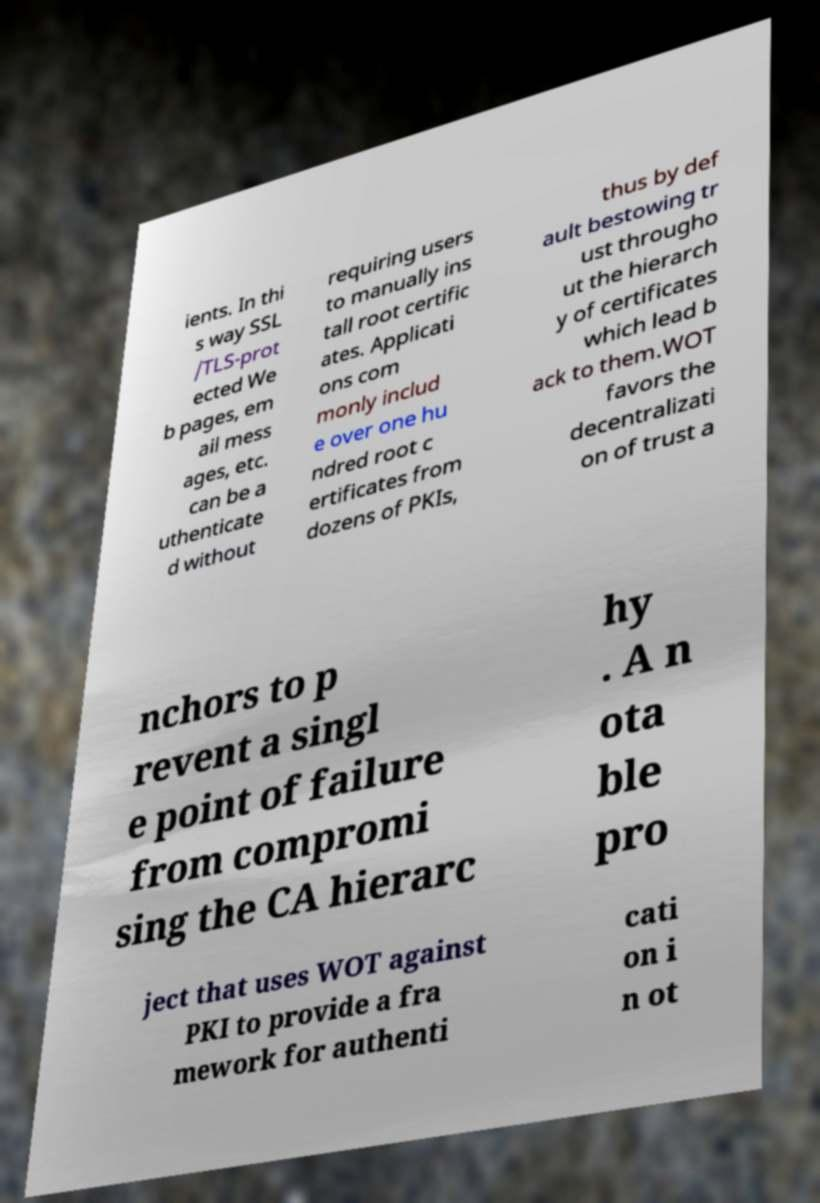Please read and relay the text visible in this image. What does it say? ients. In thi s way SSL /TLS-prot ected We b pages, em ail mess ages, etc. can be a uthenticate d without requiring users to manually ins tall root certific ates. Applicati ons com monly includ e over one hu ndred root c ertificates from dozens of PKIs, thus by def ault bestowing tr ust througho ut the hierarch y of certificates which lead b ack to them.WOT favors the decentralizati on of trust a nchors to p revent a singl e point of failure from compromi sing the CA hierarc hy . A n ota ble pro ject that uses WOT against PKI to provide a fra mework for authenti cati on i n ot 